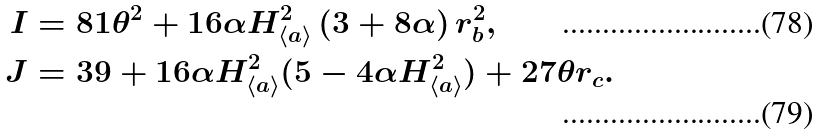Convert formula to latex. <formula><loc_0><loc_0><loc_500><loc_500>I & = 8 1 \theta ^ { 2 } + 1 6 \alpha H _ { \left \langle a \right \rangle } ^ { 2 } \left ( 3 + 8 \alpha \right ) r _ { b } ^ { 2 } , \\ J & = 3 9 + 1 6 \alpha H _ { \left \langle a \right \rangle } ^ { 2 } ( 5 - 4 \alpha H _ { \left \langle a \right \rangle } ^ { 2 } ) + 2 7 \theta r _ { c } .</formula> 